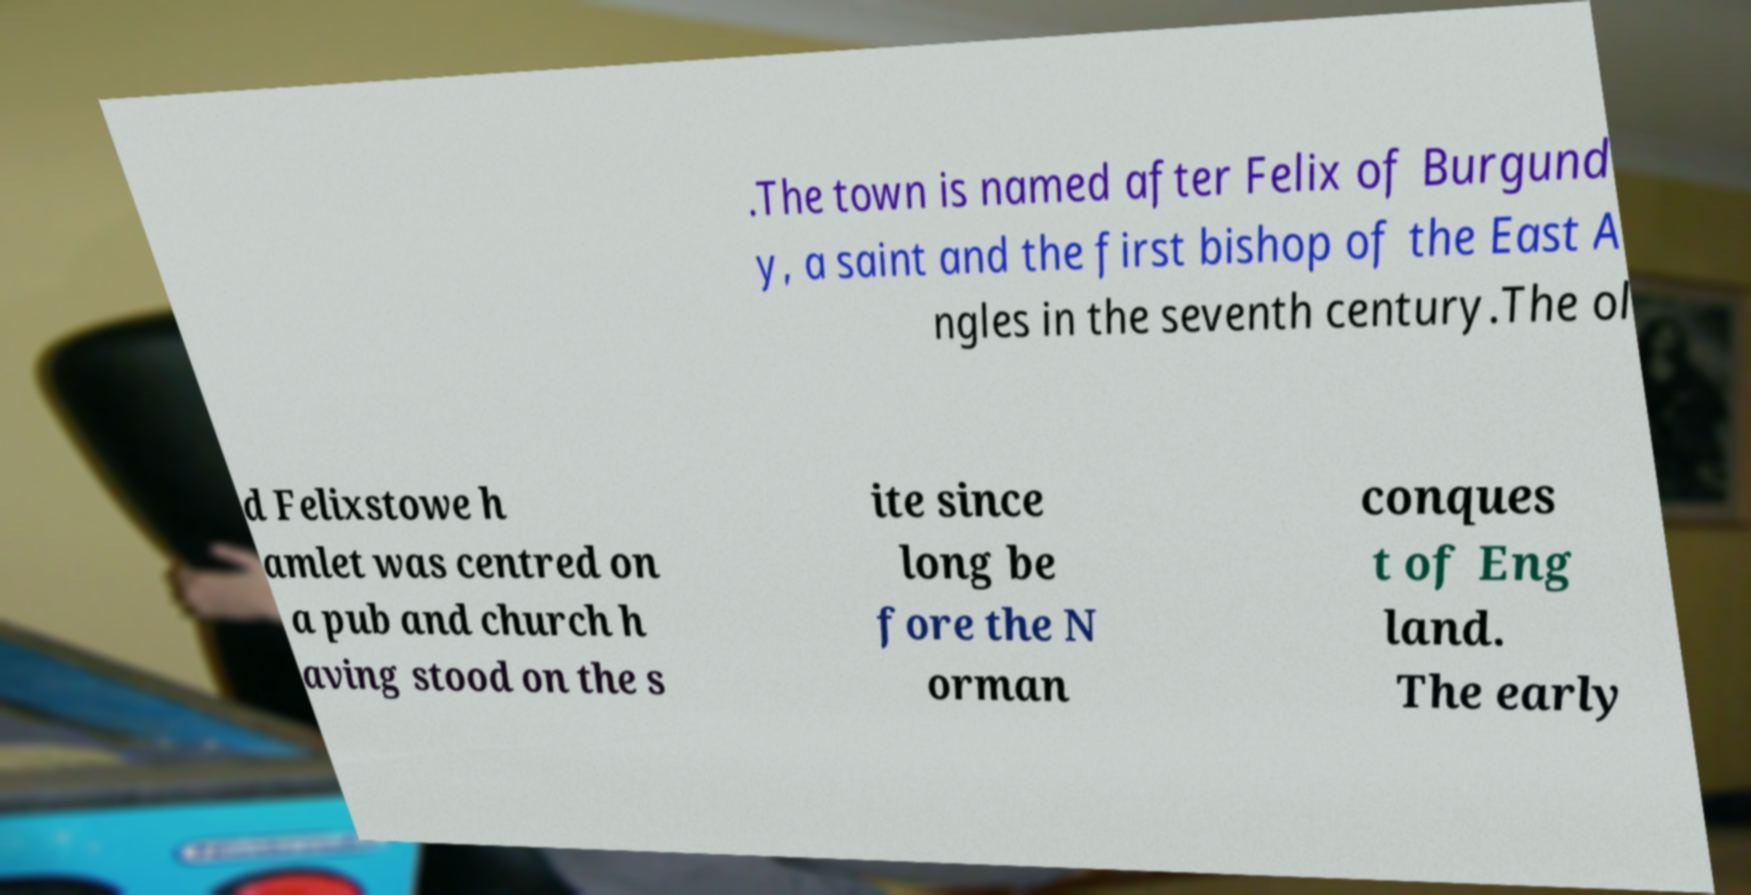There's text embedded in this image that I need extracted. Can you transcribe it verbatim? .The town is named after Felix of Burgund y, a saint and the first bishop of the East A ngles in the seventh century.The ol d Felixstowe h amlet was centred on a pub and church h aving stood on the s ite since long be fore the N orman conques t of Eng land. The early 